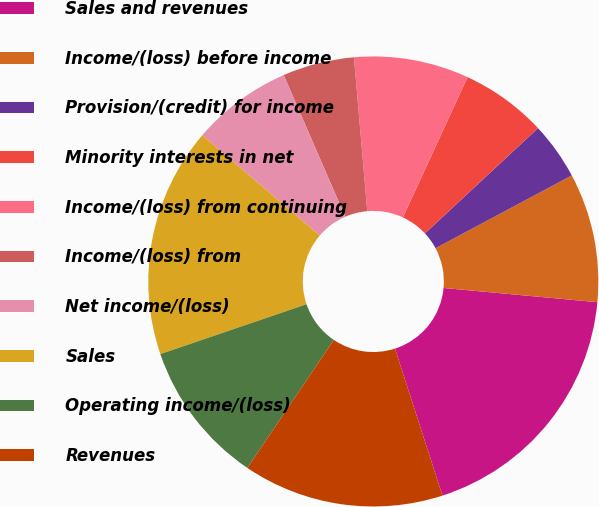<chart> <loc_0><loc_0><loc_500><loc_500><pie_chart><fcel>Sales and revenues<fcel>Income/(loss) before income<fcel>Provision/(credit) for income<fcel>Minority interests in net<fcel>Income/(loss) from continuing<fcel>Income/(loss) from<fcel>Net income/(loss)<fcel>Sales<fcel>Operating income/(loss)<fcel>Revenues<nl><fcel>18.56%<fcel>9.28%<fcel>4.12%<fcel>6.19%<fcel>8.25%<fcel>5.15%<fcel>7.22%<fcel>16.49%<fcel>10.31%<fcel>14.43%<nl></chart> 